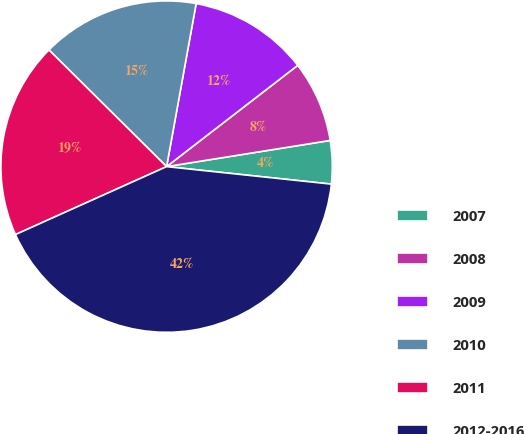Convert chart to OTSL. <chart><loc_0><loc_0><loc_500><loc_500><pie_chart><fcel>2007<fcel>2008<fcel>2009<fcel>2010<fcel>2011<fcel>2012-2016<nl><fcel>4.21%<fcel>7.94%<fcel>11.68%<fcel>15.42%<fcel>19.16%<fcel>41.59%<nl></chart> 